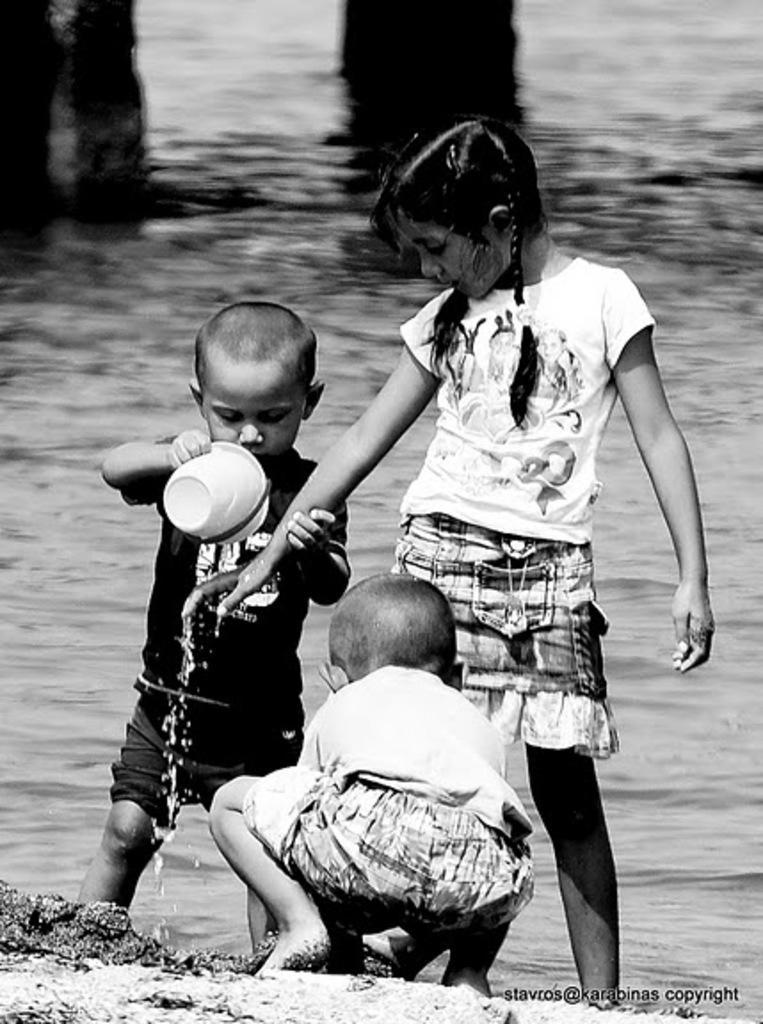In one or two sentences, can you explain what this image depicts? In this picture we can see three children, sand and a boy holding a mug with his hand and in the background we can see the water. 